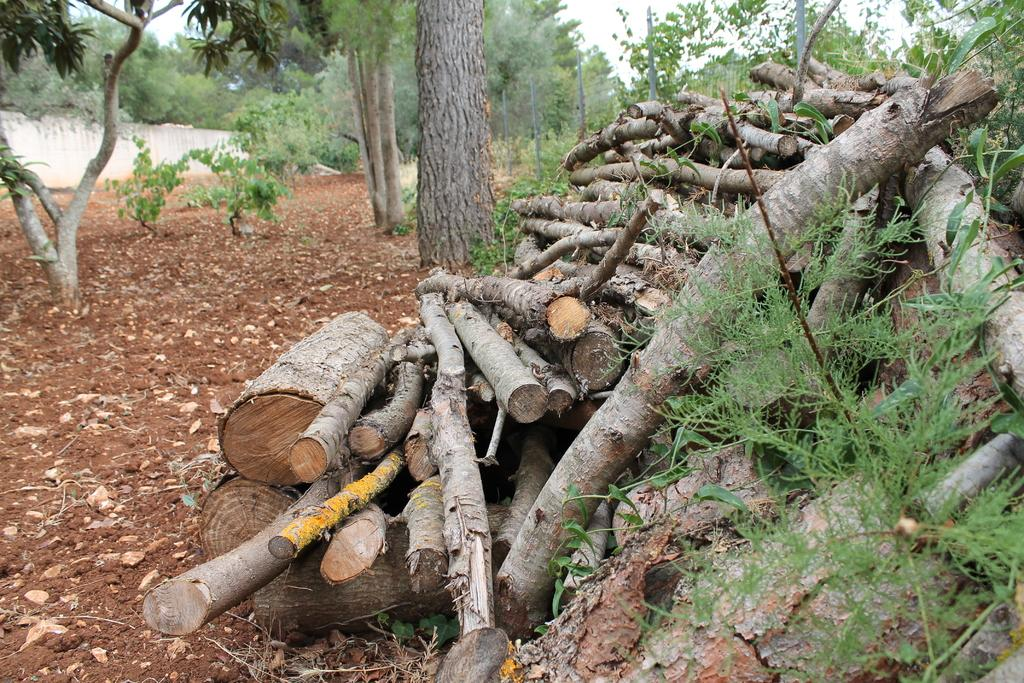What is located in the center of the image? There are logs, grass, trees, and plants in the center of the image. What is present at the top of the image? There is a mesh, sky, and a wall at the top of the image. What can be seen on the left side of the image? There is ground on the left side of the image. How does the cushion stretch in the image? There is no cushion present in the image. What type of curve can be seen in the image? There is no curve visible in the image. 